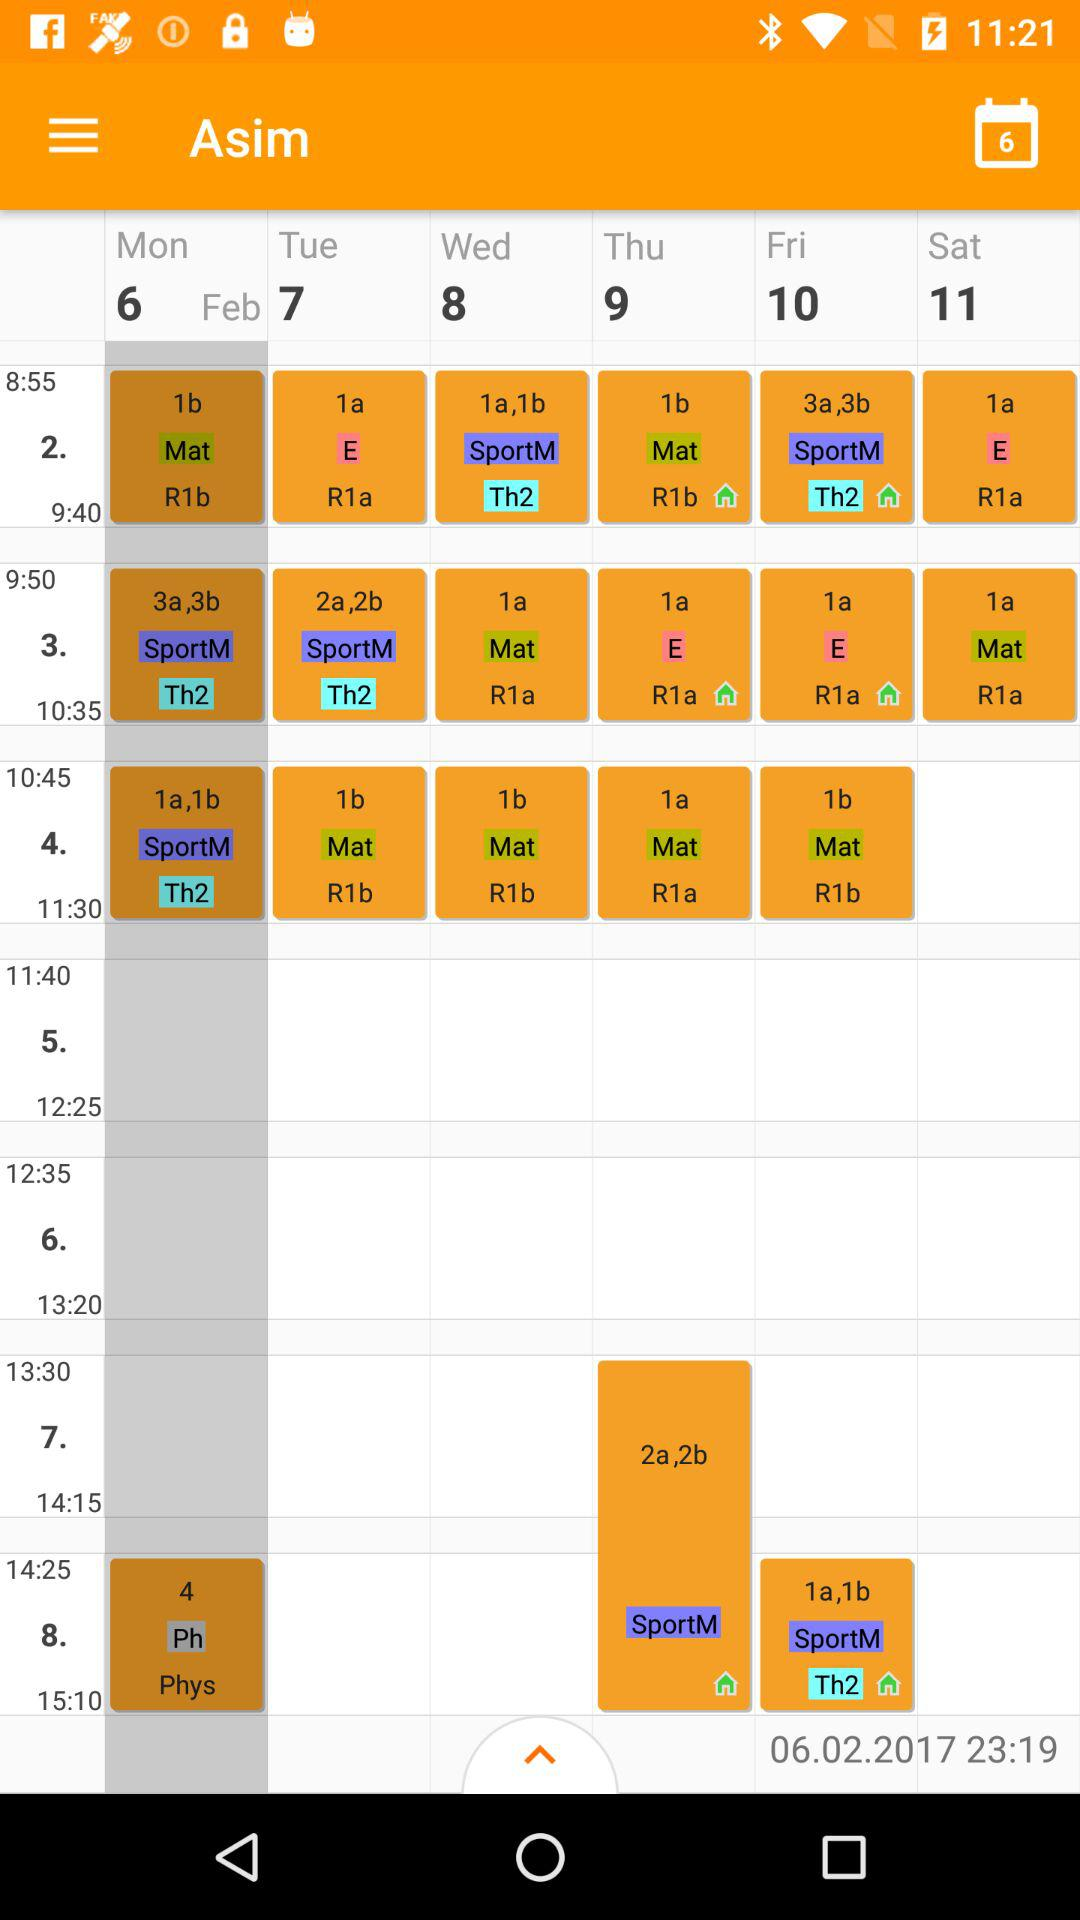What is the selected date? The selected date is 06.02.2017. 